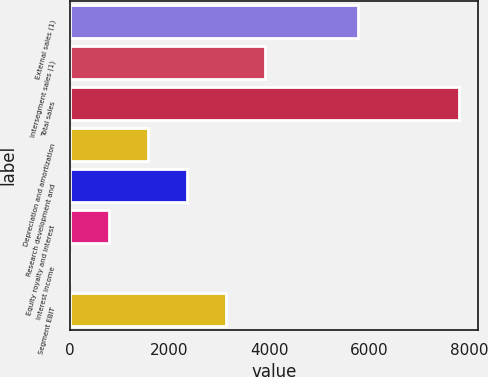<chart> <loc_0><loc_0><loc_500><loc_500><bar_chart><fcel>External sales (1)<fcel>Intersegment sales (1)<fcel>Total sales<fcel>Depreciation and amortization<fcel>Research development and<fcel>Equity royalty and interest<fcel>Interest income<fcel>Segment EBIT<nl><fcel>5774<fcel>3907<fcel>7804<fcel>1568.8<fcel>2348.2<fcel>789.4<fcel>10<fcel>3127.6<nl></chart> 